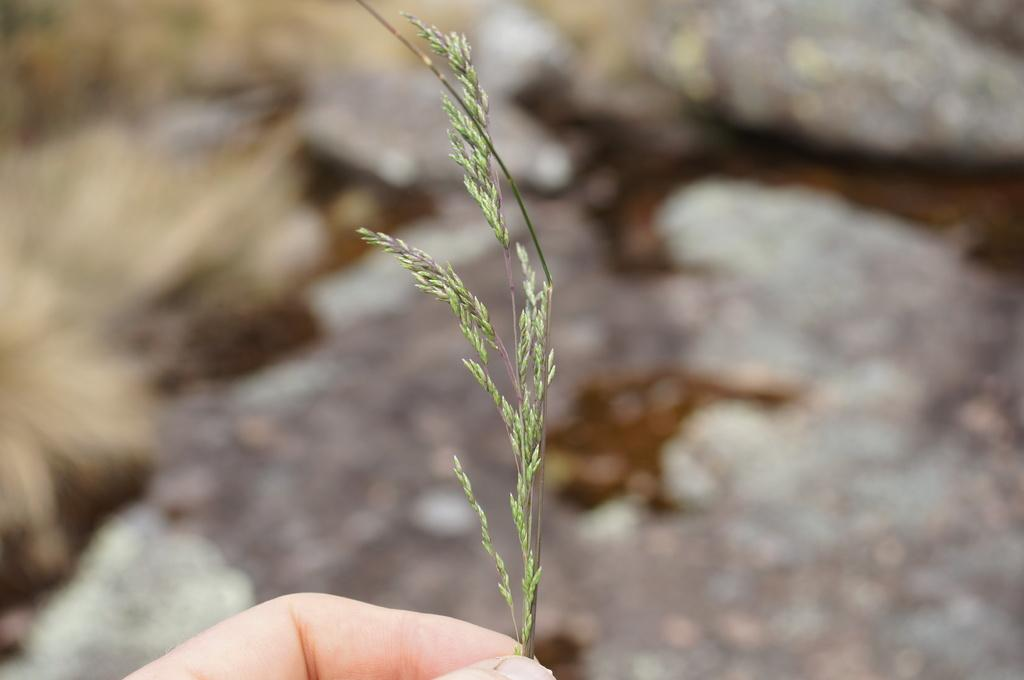What is the main subject of the image? The main subject of the image is a human hand. What is the hand holding? The hand is holding grass. Are there any other objects or elements in the image? Yes, there is a stone in the image. What type of waves can be seen crashing against the shore in the image? There are no waves present in the image; it features a human hand holding grass and a stone. Can you describe the rose that is being held by the hand in the image? There is no rose present in the image; the hand is holding grass. 